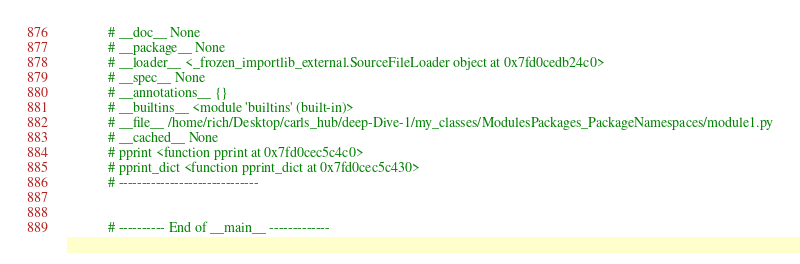Convert code to text. <code><loc_0><loc_0><loc_500><loc_500><_Python_>            # __doc__ None
            # __package__ None
            # __loader__ <_frozen_importlib_external.SourceFileLoader object at 0x7fd0cedb24c0>
            # __spec__ None
            # __annotations__ {}
            # __builtins__ <module 'builtins' (built-in)>
            # __file__ /home/rich/Desktop/carls_hub/deep-Dive-1/my_classes/ModulesPackages_PackageNamespaces/module1.py
            # __cached__ None
            # pprint <function pprint at 0x7fd0cec5c4c0>
            # pprint_dict <function pprint_dict at 0x7fd0cec5c430>
            # ------------------------------


            # ---------- End of __main__ -------------


</code> 